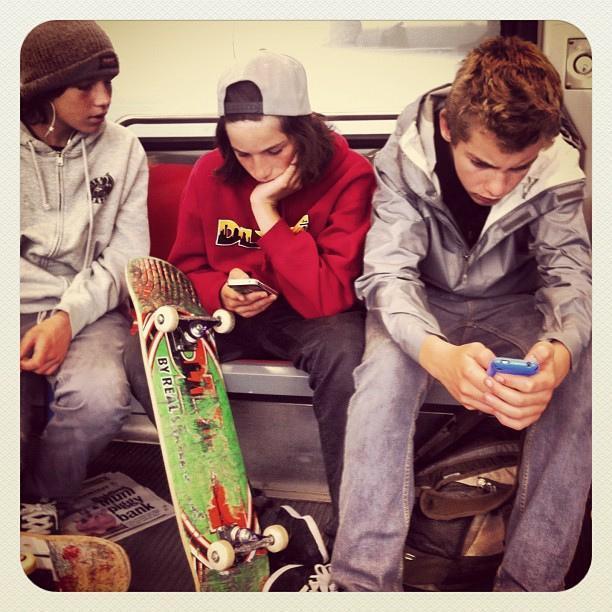How many people are wearing hats?
Give a very brief answer. 2. How many boys are looking at their cell phones?
Give a very brief answer. 2. How many skateboards are visible?
Give a very brief answer. 2. How many people can you see?
Give a very brief answer. 3. 